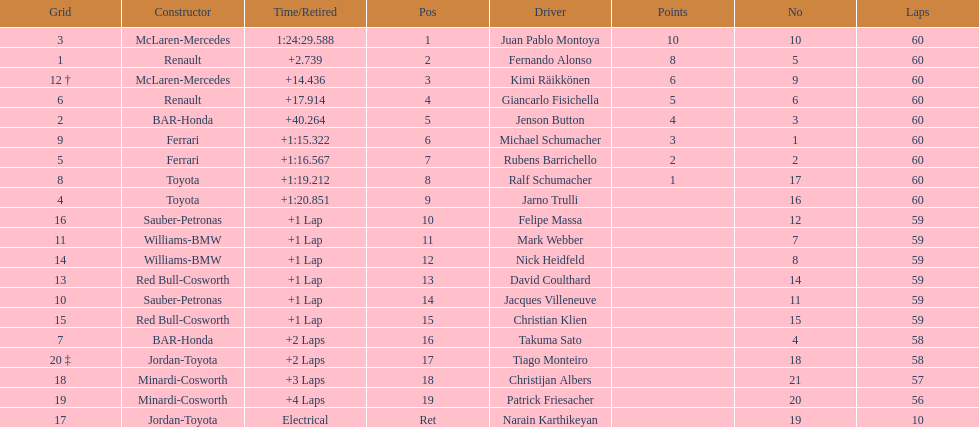Is there a points difference between the 9th position and 19th position on the list? No. 